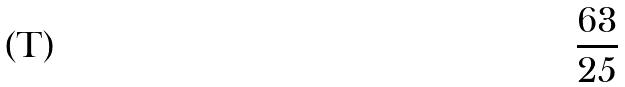<formula> <loc_0><loc_0><loc_500><loc_500>\frac { 6 3 } { 2 5 }</formula> 